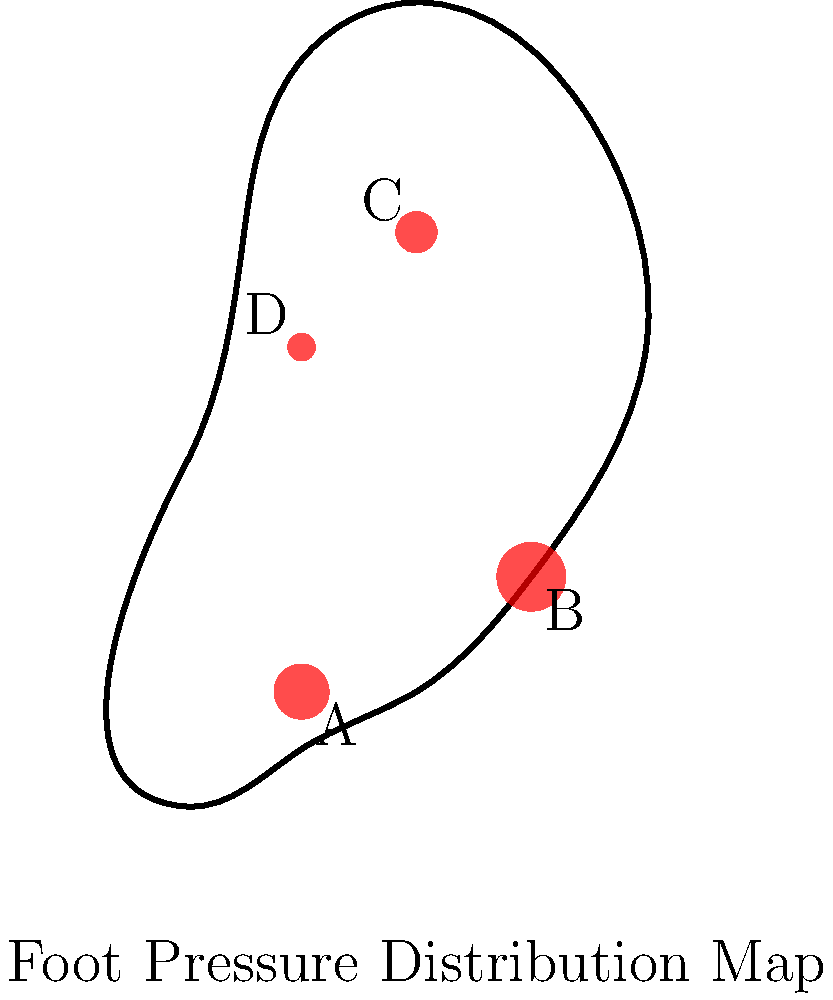In the foot pressure distribution map shown above, which area demonstrates the highest pressure during the stance phase of gait, and what does this indicate about the individual's foot mechanics? To answer this question, we need to analyze the foot pressure distribution map and understand its implications for gait mechanics. Let's break it down step-by-step:

1. Observe the pressure points: The map shows four main pressure areas labeled A, B, C, and D.

2. Compare the sizes of the pressure points: The size of each circle represents the relative pressure at that point. Larger circles indicate higher pressure.

3. Identify the highest pressure area: Area B has the largest circle, indicating the highest pressure during the stance phase.

4. Interpret the location of the highest pressure:
   - Area B is located in the forefoot region, specifically under the metatarsal heads.
   - High pressure in this area suggests increased loading on the forefoot during push-off.

5. Consider the implications for foot mechanics:
   - Increased forefoot pressure can indicate:
     a) A forefoot striker running pattern
     b) Possible weakness in the posterior leg muscles (calf and soleus)
     c) Reduced arch support or flat feet (pes planus)

6. Analyze other pressure points:
   - Area A: Moderate pressure on the lateral heel
   - Area C: Lower pressure on the medial midfoot
   - Area D: Lowest pressure on the lateral midfoot

7. Overall gait interpretation:
   - The pressure distribution suggests a gait pattern with higher loading on the forefoot and lateral heel, which could indicate a tendency towards supination or underpronation.

Understanding this pressure distribution is crucial for assessing gait efficiency, identifying potential injury risks, and designing appropriate interventions or footwear modifications to optimize performance and reduce the risk of injuries.
Answer: Area B (forefoot); indicates increased forefoot loading during push-off, possibly due to forefoot striking, weak posterior leg muscles, or reduced arch support. 